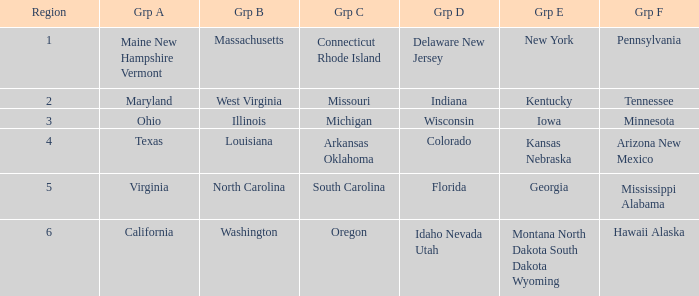What is the group B region with a Group E region of Georgia? North Carolina. 